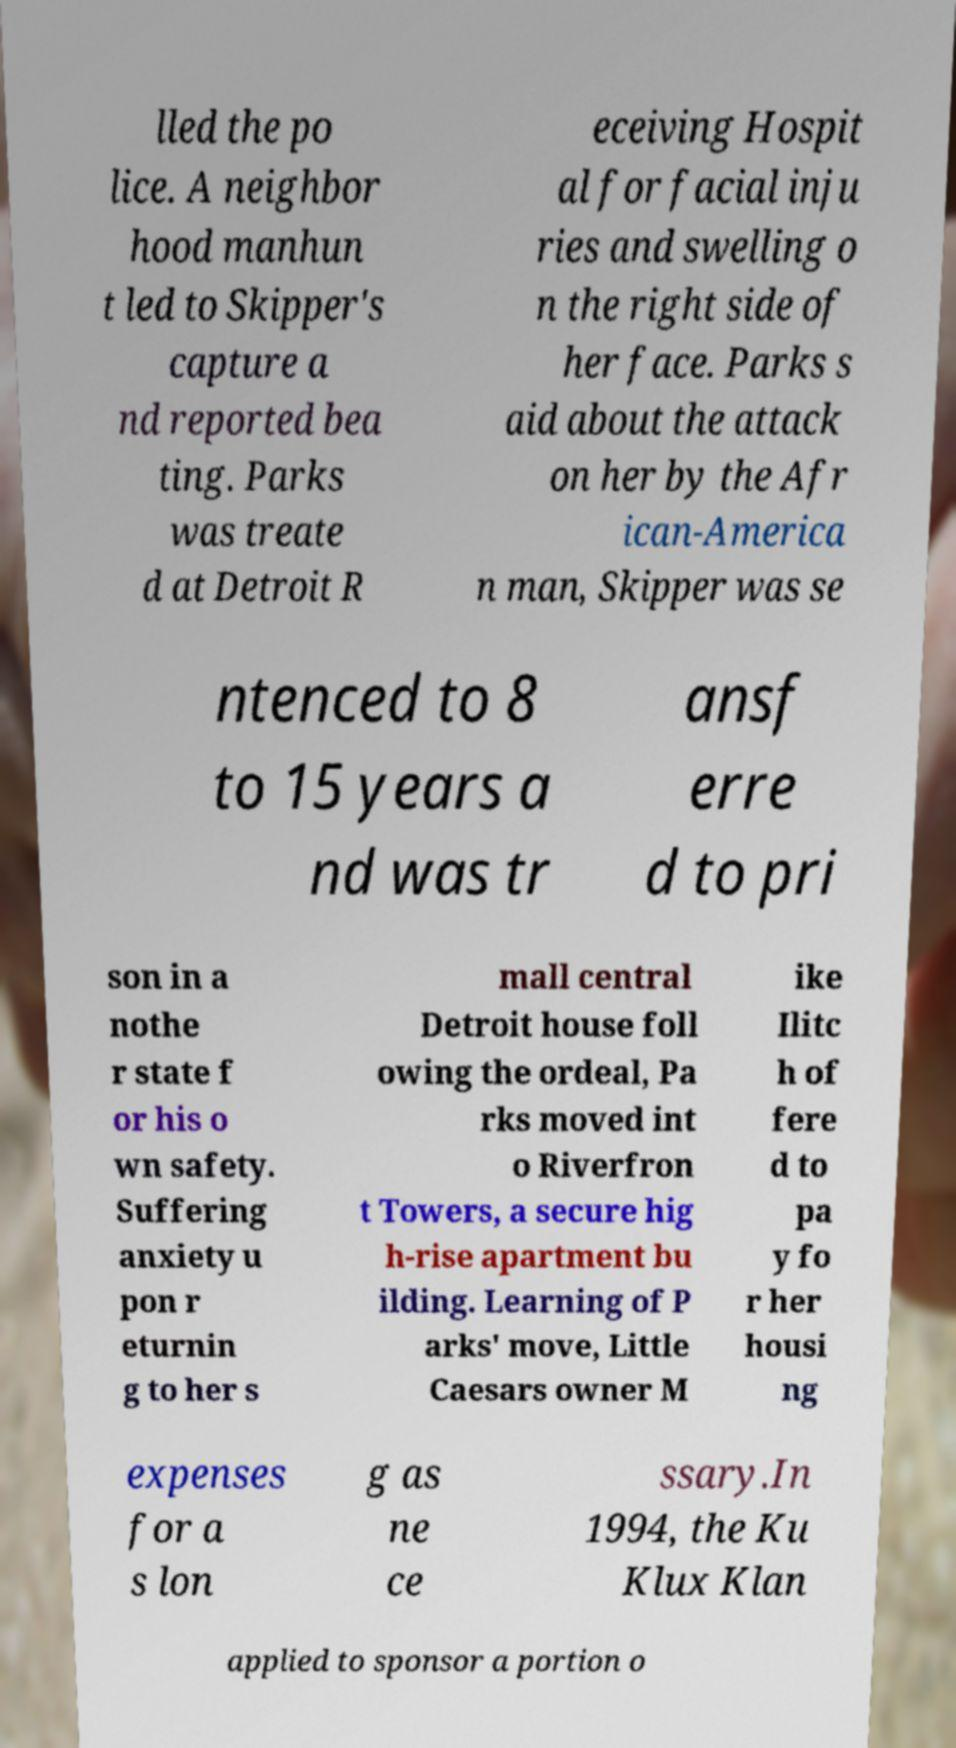There's text embedded in this image that I need extracted. Can you transcribe it verbatim? lled the po lice. A neighbor hood manhun t led to Skipper's capture a nd reported bea ting. Parks was treate d at Detroit R eceiving Hospit al for facial inju ries and swelling o n the right side of her face. Parks s aid about the attack on her by the Afr ican-America n man, Skipper was se ntenced to 8 to 15 years a nd was tr ansf erre d to pri son in a nothe r state f or his o wn safety. Suffering anxiety u pon r eturnin g to her s mall central Detroit house foll owing the ordeal, Pa rks moved int o Riverfron t Towers, a secure hig h-rise apartment bu ilding. Learning of P arks' move, Little Caesars owner M ike Ilitc h of fere d to pa y fo r her housi ng expenses for a s lon g as ne ce ssary.In 1994, the Ku Klux Klan applied to sponsor a portion o 